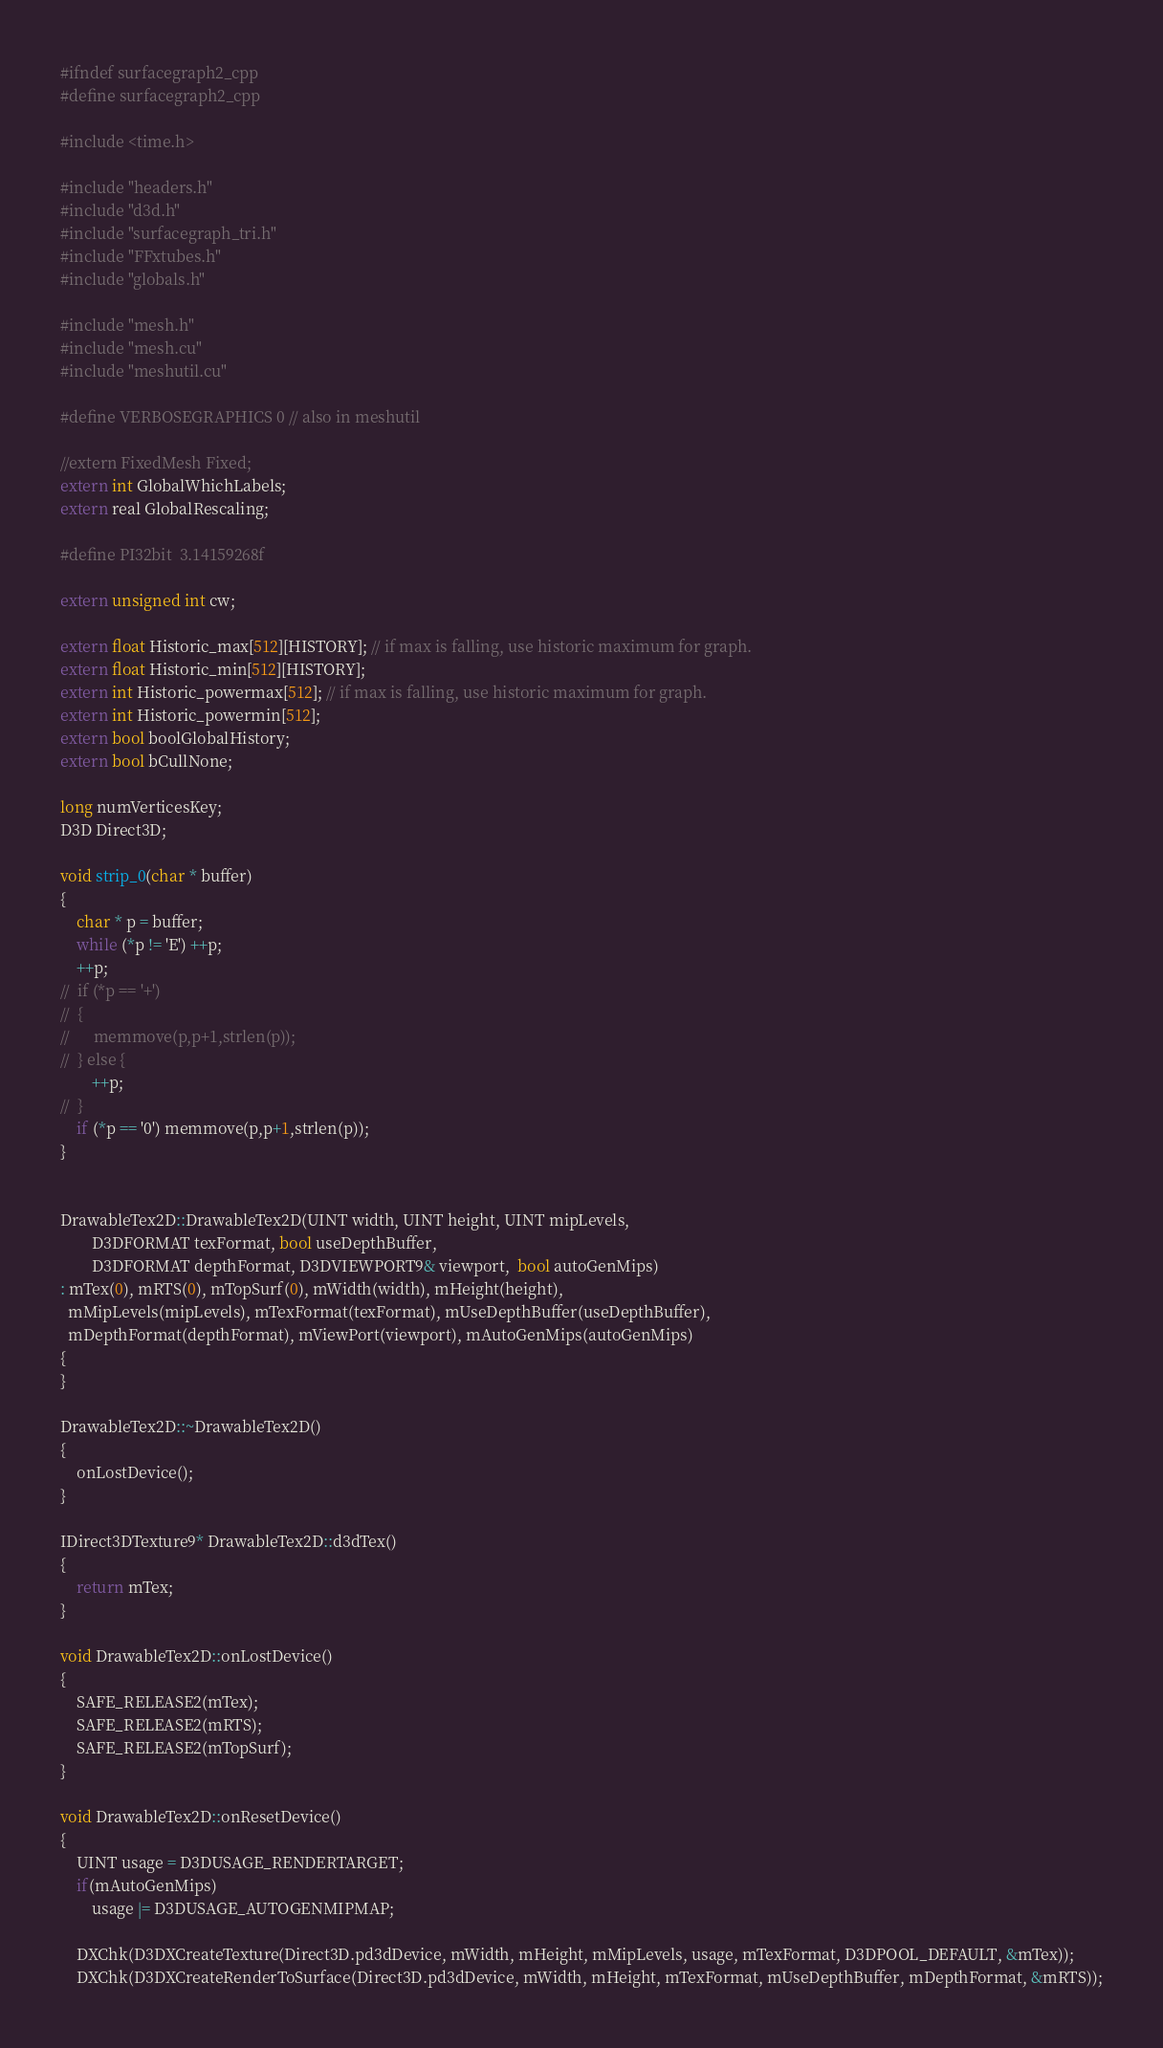<code> <loc_0><loc_0><loc_500><loc_500><_Cuda_>
#ifndef surfacegraph2_cpp
#define surfacegraph2_cpp

#include <time.h>

#include "headers.h"
#include "d3d.h"
#include "surfacegraph_tri.h"
#include "FFxtubes.h"
#include "globals.h"

#include "mesh.h"
#include "mesh.cu"
#include "meshutil.cu"

#define VERBOSEGRAPHICS 0 // also in meshutil

//extern FixedMesh Fixed;
extern int GlobalWhichLabels;
extern real GlobalRescaling;

#define PI32bit  3.14159268f

extern unsigned int cw;

extern float Historic_max[512][HISTORY]; // if max is falling, use historic maximum for graph.
extern float Historic_min[512][HISTORY];
extern int Historic_powermax[512]; // if max is falling, use historic maximum for graph.
extern int Historic_powermin[512];
extern bool boolGlobalHistory;
extern bool bCullNone;

long numVerticesKey;
D3D Direct3D;

void strip_0(char * buffer)
{
	char * p = buffer;
	while (*p != 'E') ++p;
	++p;
//	if (*p == '+')
//	{
//		memmove(p,p+1,strlen(p));
//	} else {
		++p;
//	}
	if (*p == '0') memmove(p,p+1,strlen(p));
}


DrawableTex2D::DrawableTex2D(UINT width, UINT height, UINT mipLevels,
		D3DFORMAT texFormat, bool useDepthBuffer,
		D3DFORMAT depthFormat, D3DVIEWPORT9& viewport,  bool autoGenMips)
: mTex(0), mRTS(0), mTopSurf(0), mWidth(width), mHeight(height), 
  mMipLevels(mipLevels), mTexFormat(texFormat), mUseDepthBuffer(useDepthBuffer),
  mDepthFormat(depthFormat), mViewPort(viewport), mAutoGenMips(autoGenMips)
{
}

DrawableTex2D::~DrawableTex2D()
{
	onLostDevice();
}

IDirect3DTexture9* DrawableTex2D::d3dTex()
{
	return mTex;
}

void DrawableTex2D::onLostDevice()
{
	SAFE_RELEASE2(mTex);
	SAFE_RELEASE2(mRTS);
	SAFE_RELEASE2(mTopSurf);
}

void DrawableTex2D::onResetDevice()
{
	UINT usage = D3DUSAGE_RENDERTARGET;
	if(mAutoGenMips)
		usage |= D3DUSAGE_AUTOGENMIPMAP;

	DXChk(D3DXCreateTexture(Direct3D.pd3dDevice, mWidth, mHeight, mMipLevels, usage, mTexFormat, D3DPOOL_DEFAULT, &mTex));
	DXChk(D3DXCreateRenderToSurface(Direct3D.pd3dDevice, mWidth, mHeight, mTexFormat, mUseDepthBuffer, mDepthFormat, &mRTS));</code> 